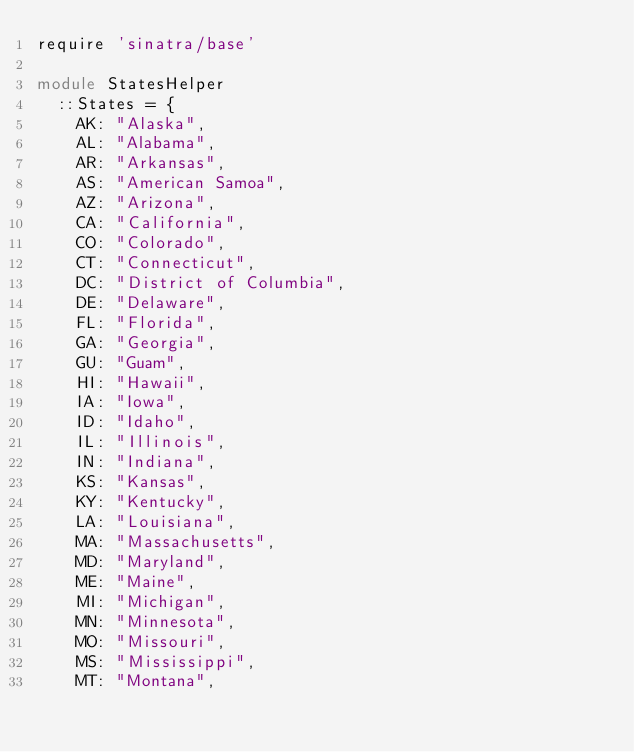<code> <loc_0><loc_0><loc_500><loc_500><_Ruby_>require 'sinatra/base'

module StatesHelper
  ::States = {
    AK: "Alaska",
    AL: "Alabama",
    AR: "Arkansas",
    AS: "American Samoa",
    AZ: "Arizona",
    CA: "California",
    CO: "Colorado",
    CT: "Connecticut",
    DC: "District of Columbia",
    DE: "Delaware",
    FL: "Florida",
    GA: "Georgia",
    GU: "Guam",
    HI: "Hawaii",
    IA: "Iowa",
    ID: "Idaho",
    IL: "Illinois",
    IN: "Indiana",
    KS: "Kansas",
    KY: "Kentucky",
    LA: "Louisiana",
    MA: "Massachusetts",
    MD: "Maryland",
    ME: "Maine",
    MI: "Michigan",
    MN: "Minnesota",
    MO: "Missouri",
    MS: "Mississippi",
    MT: "Montana",</code> 